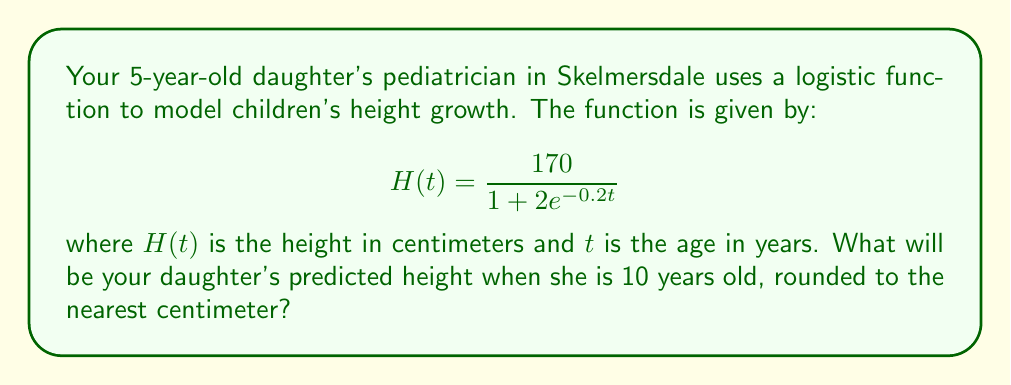Solve this math problem. To solve this problem, we need to follow these steps:

1. Understand the given logistic function:
   $$H(t) = \frac{170}{1 + 2e^{-0.2t}}$$
   where $H(t)$ is the height in centimeters and $t$ is the age in years.

2. We need to find $H(10)$, as we want to know the height at 10 years old.

3. Substitute $t = 10$ into the function:
   $$H(10) = \frac{170}{1 + 2e^{-0.2(10)}}$$

4. Simplify the exponent:
   $$H(10) = \frac{170}{1 + 2e^{-2}}$$

5. Calculate $e^{-2}$ (you can use a calculator for this):
   $e^{-2} \approx 0.1353$

6. Substitute this value:
   $$H(10) = \frac{170}{1 + 2(0.1353)} = \frac{170}{1 + 0.2706}$$

7. Simplify the denominator:
   $$H(10) = \frac{170}{1.2706}$$

8. Divide:
   $$H(10) \approx 133.7952$$

9. Round to the nearest centimeter:
   $$H(10) \approx 134\text{ cm}$$
Answer: 134 cm 